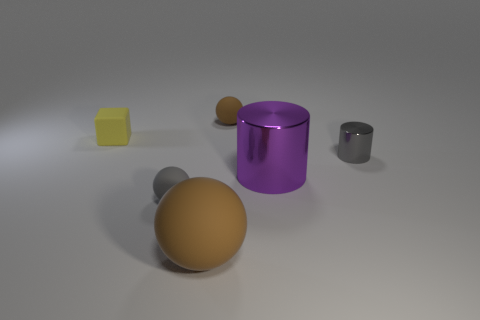Subtract all brown spheres. How many spheres are left? 1 Add 4 gray cylinders. How many objects exist? 10 Subtract 1 cubes. How many cubes are left? 0 Subtract all purple cylinders. How many brown spheres are left? 2 Subtract all cyan rubber things. Subtract all large metallic cylinders. How many objects are left? 5 Add 1 cylinders. How many cylinders are left? 3 Add 6 large brown balls. How many large brown balls exist? 7 Subtract all gray cylinders. How many cylinders are left? 1 Subtract 1 gray cylinders. How many objects are left? 5 Subtract all cubes. How many objects are left? 5 